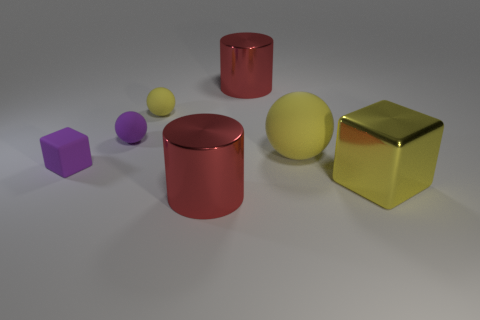Add 1 large red shiny things. How many objects exist? 8 Subtract all cubes. How many objects are left? 5 Subtract all tiny blue shiny cylinders. Subtract all small purple rubber objects. How many objects are left? 5 Add 2 purple cubes. How many purple cubes are left? 3 Add 4 purple cubes. How many purple cubes exist? 5 Subtract 0 green blocks. How many objects are left? 7 